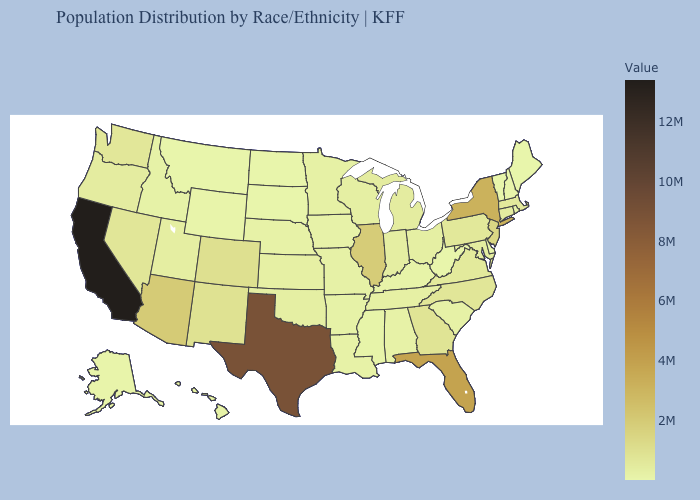Does Vermont have the lowest value in the Northeast?
Keep it brief. Yes. Does Colorado have the lowest value in the USA?
Write a very short answer. No. Does the map have missing data?
Answer briefly. No. Among the states that border New York , does New Jersey have the highest value?
Answer briefly. Yes. Among the states that border Wyoming , which have the lowest value?
Short answer required. South Dakota. Does Maine have the lowest value in the Northeast?
Be succinct. No. 